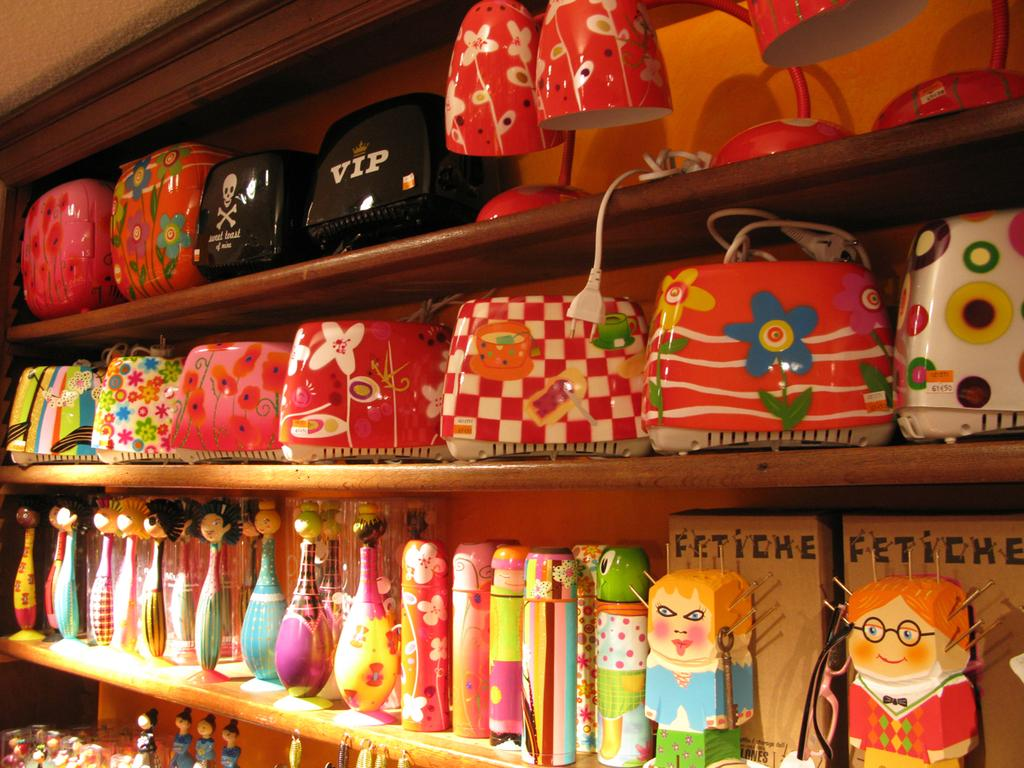What type of objects can be seen in the image? There are toys, cables, boxes, and objects in racks in the image. Can you describe the arrangement of the objects in the image? The toys, cables, and boxes are visible, as well as objects in racks. What might be the purpose of the cables in the image? The purpose of the cables in the image is not explicitly stated, but they may be used for connecting or powering electronic devices. How are the objects in racks arranged in the image? The objects in racks are arranged in rows or columns, with each object occupying a specific space. What is the limit of the heart's capacity in the image? There is no mention of a heart or its capacity in the image; it features toys, cables, boxes, and objects in racks. 